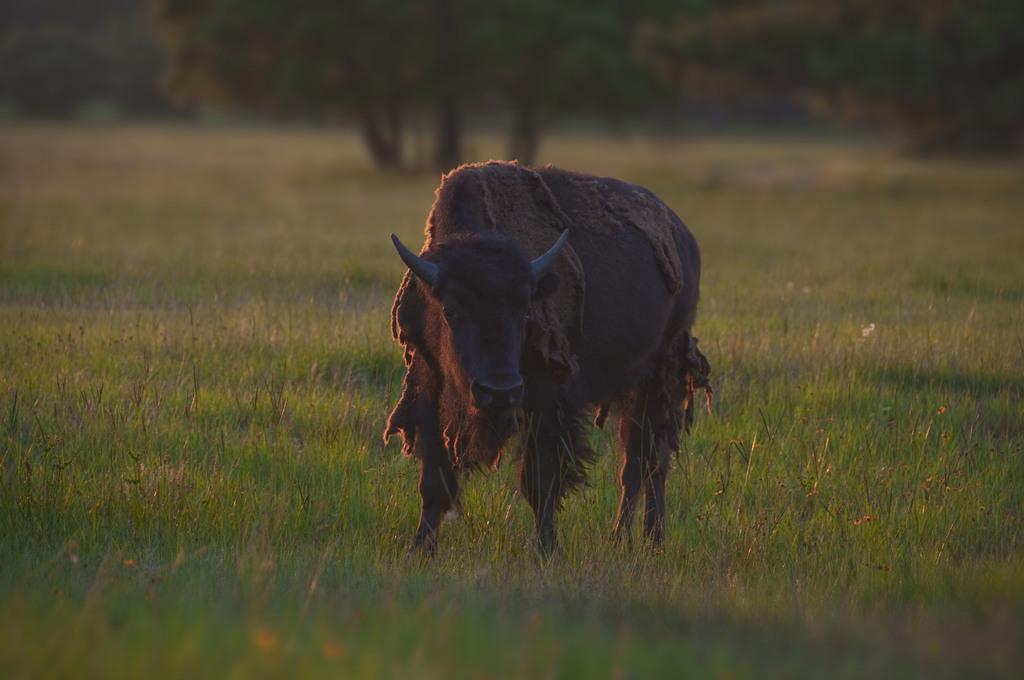How would you summarize this image in a sentence or two? In this image we can see a wild bull which is of brown color standing and at the background of the image there are some trees. 